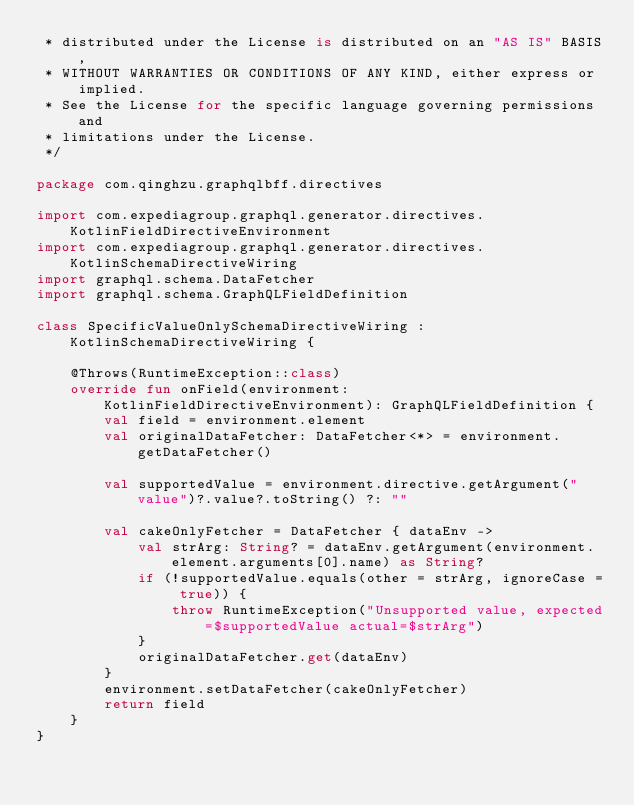Convert code to text. <code><loc_0><loc_0><loc_500><loc_500><_Kotlin_> * distributed under the License is distributed on an "AS IS" BASIS,
 * WITHOUT WARRANTIES OR CONDITIONS OF ANY KIND, either express or implied.
 * See the License for the specific language governing permissions and
 * limitations under the License.
 */

package com.qinghzu.graphqlbff.directives

import com.expediagroup.graphql.generator.directives.KotlinFieldDirectiveEnvironment
import com.expediagroup.graphql.generator.directives.KotlinSchemaDirectiveWiring
import graphql.schema.DataFetcher
import graphql.schema.GraphQLFieldDefinition

class SpecificValueOnlySchemaDirectiveWiring : KotlinSchemaDirectiveWiring {

    @Throws(RuntimeException::class)
    override fun onField(environment: KotlinFieldDirectiveEnvironment): GraphQLFieldDefinition {
        val field = environment.element
        val originalDataFetcher: DataFetcher<*> = environment.getDataFetcher()

        val supportedValue = environment.directive.getArgument("value")?.value?.toString() ?: ""

        val cakeOnlyFetcher = DataFetcher { dataEnv ->
            val strArg: String? = dataEnv.getArgument(environment.element.arguments[0].name) as String?
            if (!supportedValue.equals(other = strArg, ignoreCase = true)) {
                throw RuntimeException("Unsupported value, expected=$supportedValue actual=$strArg")
            }
            originalDataFetcher.get(dataEnv)
        }
        environment.setDataFetcher(cakeOnlyFetcher)
        return field
    }
}
</code> 